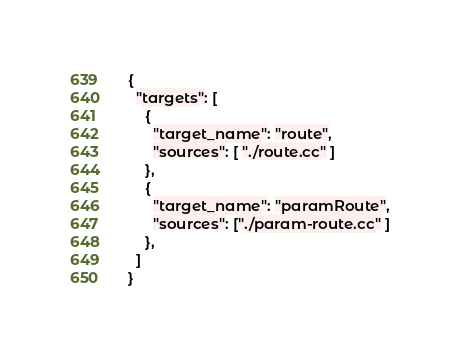Convert code to text. <code><loc_0><loc_0><loc_500><loc_500><_Python_>{
  "targets": [
    {
      "target_name": "route",
      "sources": [ "./route.cc" ]
    },
    {
      "target_name": "paramRoute",
      "sources": ["./param-route.cc" ]
    },
  ]
}
</code> 